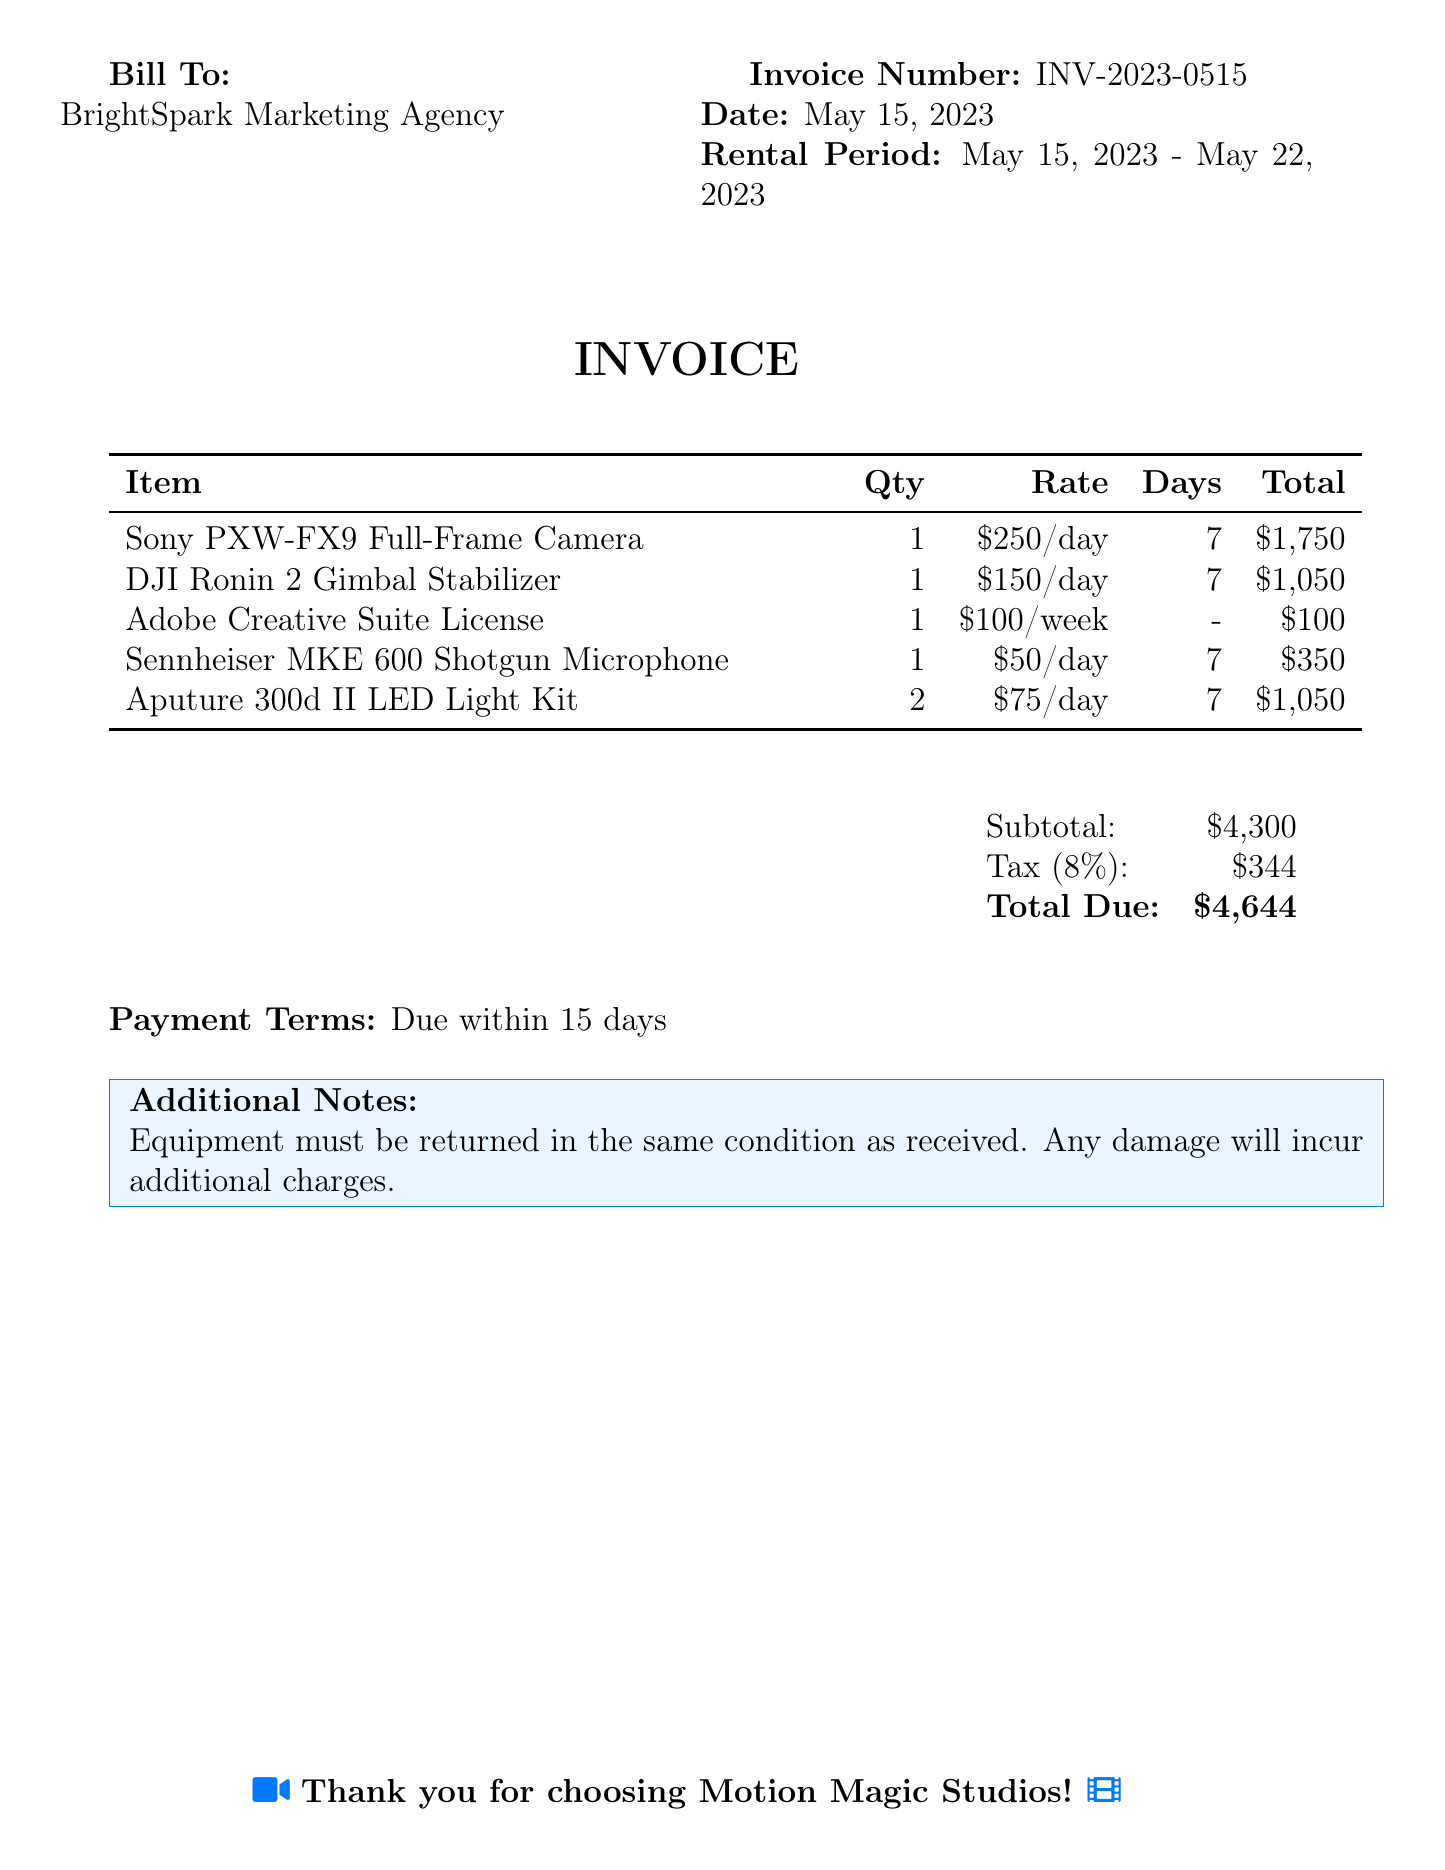What is the invoice number? The invoice number is provided in the document under the "Invoice Number" section.
Answer: INV-2023-0515 What is the total due amount? The total amount due is calculated by adding the subtotal and tax, found in the payment summary section.
Answer: $4,644 When is the payment due? The payment terms specify when payment is required, which is stated clearly in the document.
Answer: Due within 15 days How many days was the equipment rented? The rental period is specified in the "Rental Period" section, indicating the start and end dates.
Answer: 7 What is the daily rate for the Sony PXW-FX9 Full-Frame Camera? The daily rate for this camera is indicated in the itemized breakdown of the bill.
Answer: $250/day What is the quantity of Aputure 300d II LED Light Kits rented? The quantity is listed in the itemized section of the bill.
Answer: 2 What is the tax rate applied? The tax percentage is clearly shown in the payment summary of the document.
Answer: 8% What additional charges may be incurred? The document specifies conditions for additional charges, related to the return of the equipment.
Answer: Damage 